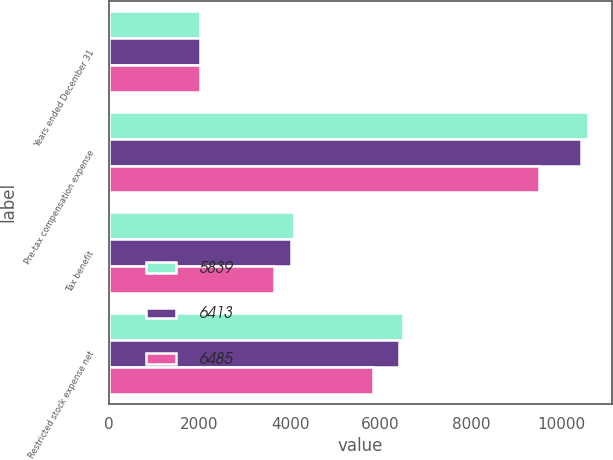<chart> <loc_0><loc_0><loc_500><loc_500><stacked_bar_chart><ecel><fcel>Years ended December 31<fcel>Pre-tax compensation expense<fcel>Tax benefit<fcel>Restricted stock expense net<nl><fcel>5839<fcel>2014<fcel>10579<fcel>4094<fcel>6485<nl><fcel>6413<fcel>2013<fcel>10427<fcel>4014<fcel>6413<nl><fcel>6485<fcel>2012<fcel>9494<fcel>3655<fcel>5839<nl></chart> 